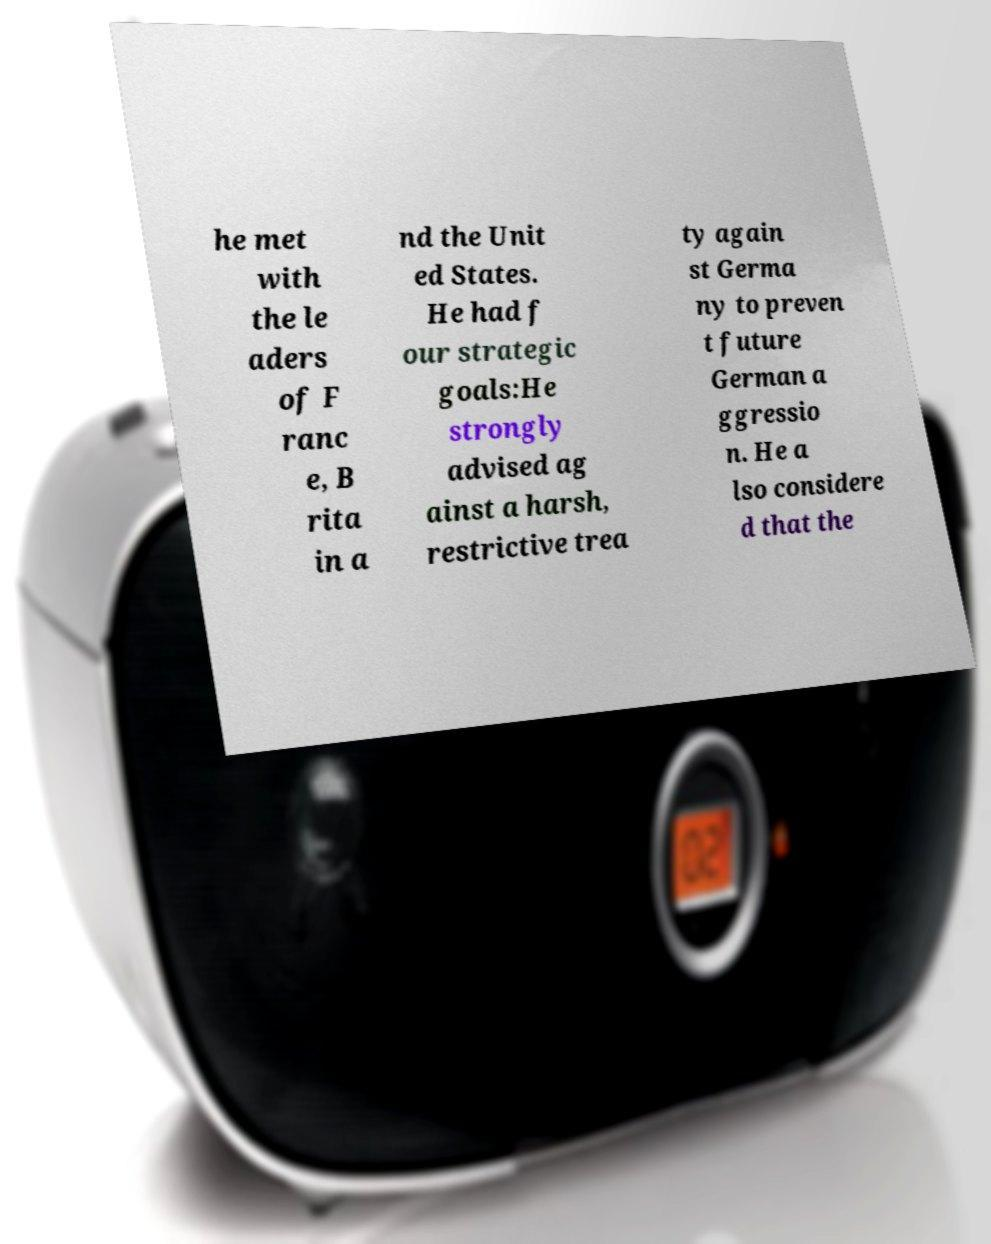What messages or text are displayed in this image? I need them in a readable, typed format. he met with the le aders of F ranc e, B rita in a nd the Unit ed States. He had f our strategic goals:He strongly advised ag ainst a harsh, restrictive trea ty again st Germa ny to preven t future German a ggressio n. He a lso considere d that the 